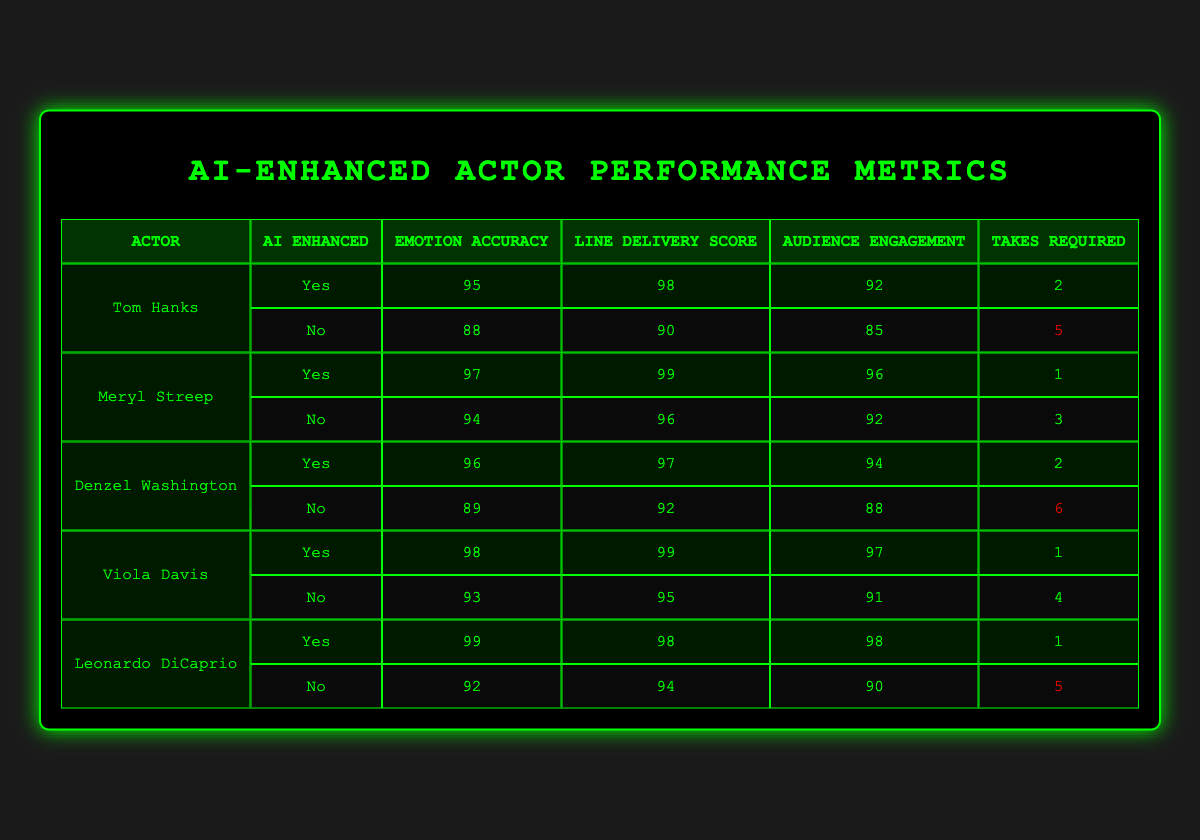What is the emotion accuracy of Tom Hanks in the "Emotional Breakdown" scene? The table shows that in the "Emotional Breakdown" scene with AI-enhanced direction, Tom Hanks has an emotion accuracy of 95.
Answer: 95 In which scene did Viola Davis require the fewest takes? From the table, Viola Davis required only 1 take in the "Courtroom Drama" scene, which is fewer than her other scene, "Family Reunion," where she required 4 takes.
Answer: 1 What is the average line delivery score for AI-enhanced performances? The AI-enhanced line delivery scores are 98, 99, 97, 99, and 98. Summing these gives 491, and there are 5 performances, so the average is 491/5 = 98.2.
Answer: 98.2 Did Denzel Washington perform better in terms of audience engagement with AI-enhanced direction? Denzel Washington's audience engagement score with AI-enhanced direction is 94, compared to 88 without it, indicating he performed better with AI.
Answer: Yes Which actor had the highest emotion accuracy in an AI-enhanced scene, and what was the value? In the AI-enhanced scenes, Leonardo DiCaprio had the highest emotion accuracy of 99 in the "Dream Sequence."
Answer: Leonardo DiCaprio, 99 What is the total number of takes required by Meryl Streep across both scenes? Meryl Streep required 1 take in "Revelation" and 3 takes in "Climax." Adding these gives a total of 1 + 3 = 4 takes.
Answer: 4 Is there a scene in which AI-enhanced performances required more takes than non-AI-enhanced? Based on the table, all AI-enhanced performances required fewer or equal takes than their non-AI-enhanced counterparts, so the answer is no.
Answer: No What is the difference in audience engagement between Tom Hanks's AI-enhanced performance and his non-AI-enhanced performance? Tom Hanks scored 92 with AI-enhanced direction and 85 without it. The difference is 92 - 85 = 7.
Answer: 7 Who had the lowest line delivery score without AI-enhanced direction? In the non-AI-enhanced performances, Denzel Washington had the lowest line delivery score of 92 in the "Chase Sequence."
Answer: Denzel Washington, 92 